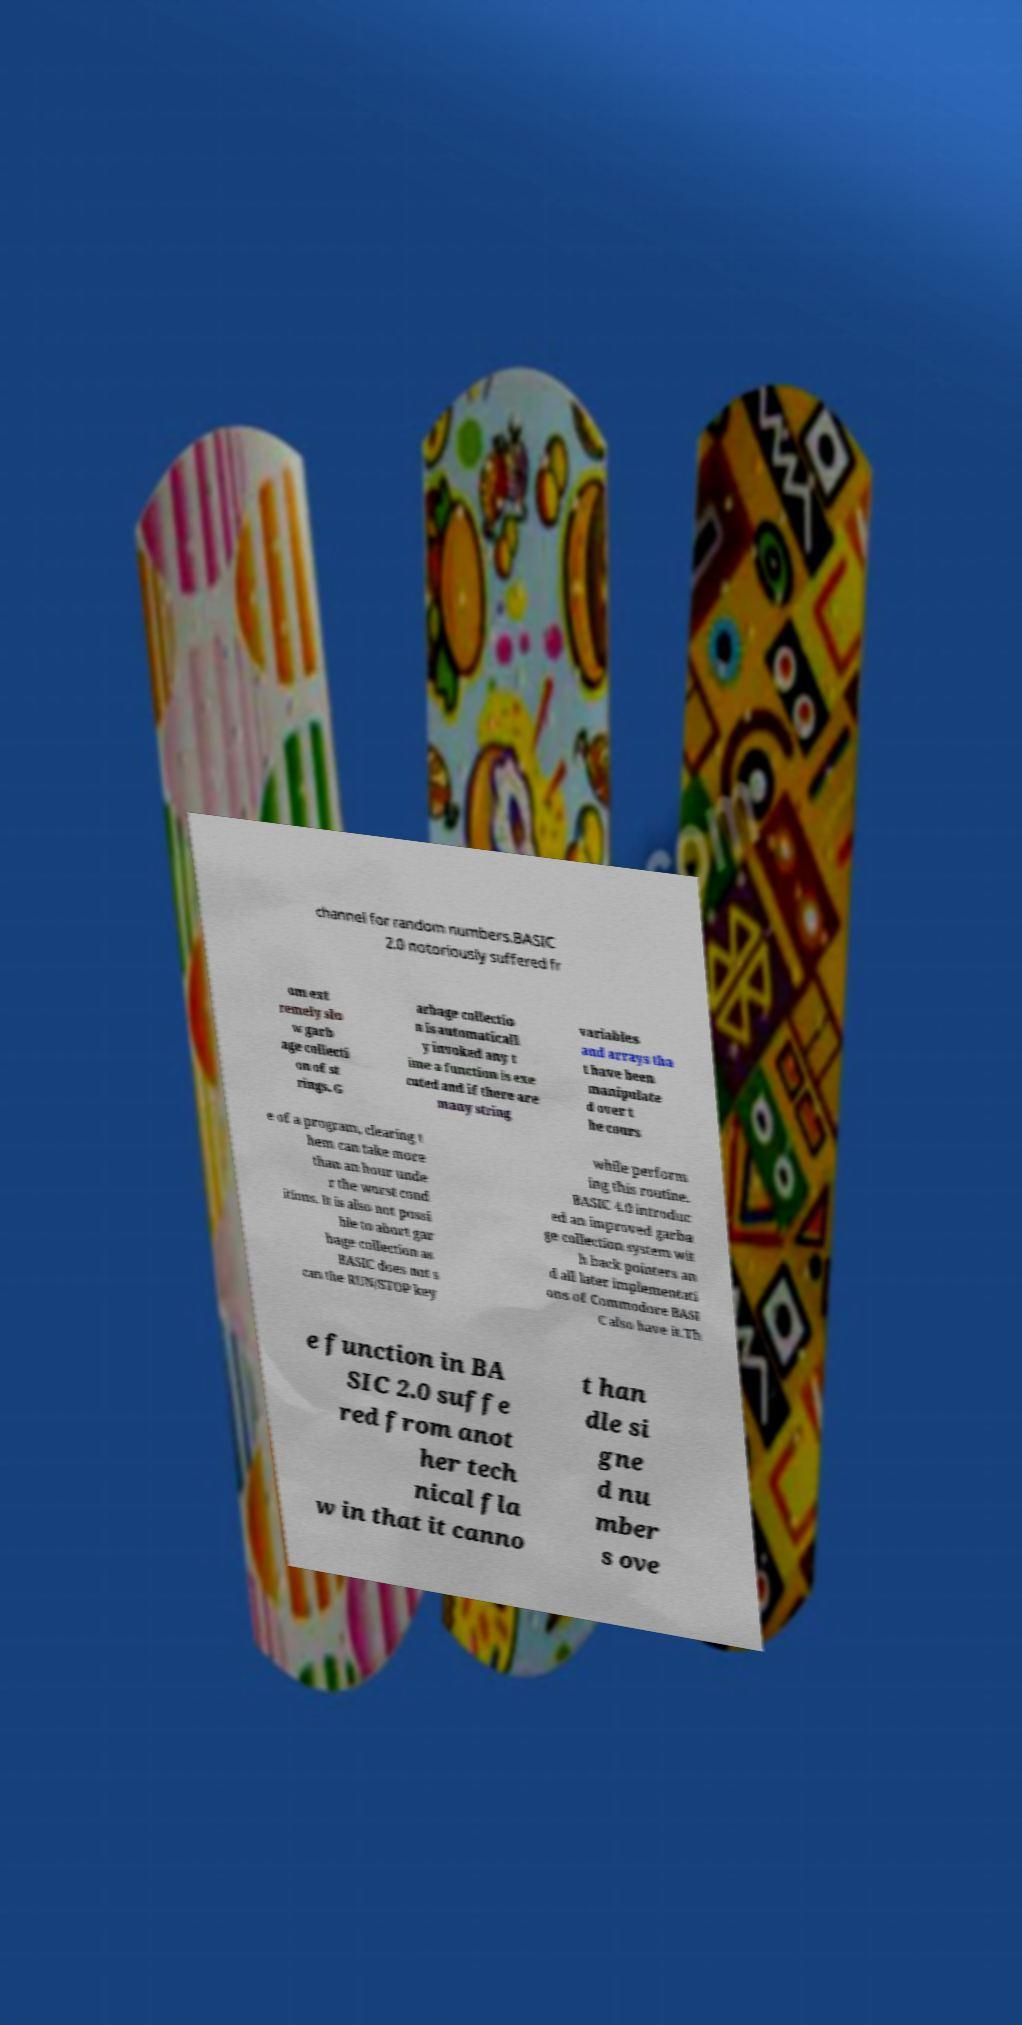Please read and relay the text visible in this image. What does it say? channel for random numbers.BASIC 2.0 notoriously suffered fr om ext remely slo w garb age collecti on of st rings. G arbage collectio n is automaticall y invoked any t ime a function is exe cuted and if there are many string variables and arrays tha t have been manipulate d over t he cours e of a program, clearing t hem can take more than an hour unde r the worst cond itions. It is also not possi ble to abort gar bage collection as BASIC does not s can the RUN/STOP key while perform ing this routine. BASIC 4.0 introduc ed an improved garba ge collection system wit h back pointers an d all later implementati ons of Commodore BASI C also have it.Th e function in BA SIC 2.0 suffe red from anot her tech nical fla w in that it canno t han dle si gne d nu mber s ove 